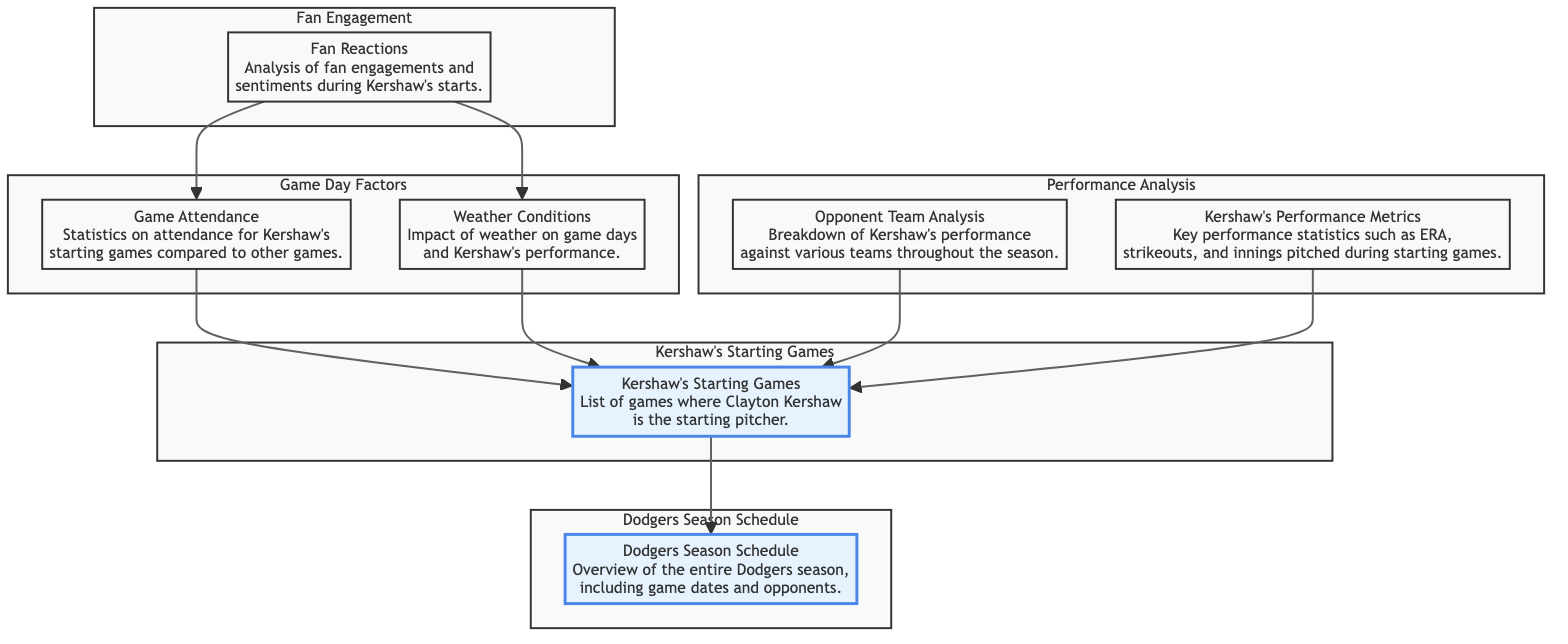What is the main focus of the diagram? The diagram focuses on the comparison between the Dodgers' season schedule, specifically the days when Kershaw is pitching and various performance metrics surrounding those games.
Answer: Seasonal Schedule Comparison How many main element groups are there in the diagram? The diagram has five main element groups: Dodgers Season Schedule, Kershaw's Starting Games, Performance Analysis, Game Day Factors, and Fan Engagement.
Answer: Five What type of game information is included in Kershaw's Starting Games? Kershaw's Starting Games provides a list of games where Clayton Kershaw is the starting pitcher.
Answer: List of games Which element analyzes attendance statistics? The Game Attendance element analyzes statistics on attendance for Kershaw's starting games compared to other games.
Answer: Game Attendance What is the purpose of the Opponent Team Analysis? The Opponent Team Analysis provides a breakdown of Kershaw's performance against various teams throughout the season to evaluate his effectiveness.
Answer: Breakdown of performance How do weather conditions relate to Kershaw's games? Weather Conditions impacts Kershaw’s performance and could affect game results and attendance.
Answer: Influences performance What type of data is highlighted in Kershaw's Performance Metrics? Kershaw's Performance Metrics includes key performance statistics such as ERA, strikeouts, and innings pitched during starting games.
Answer: Key performance statistics How does Fan Reactions connect to Game Attendance? Fan Reactions influences Game Attendance, as fan sentiment could impact attendance numbers during Kershaw’s starts.
Answer: Connections to Game Attendance Which node is considered a starting point in the diagram? The Dodgers Season Schedule is the starting point of the diagram, as it provides an overview that leads into Kershaw's performance.
Answer: Dodgers Season Schedule 